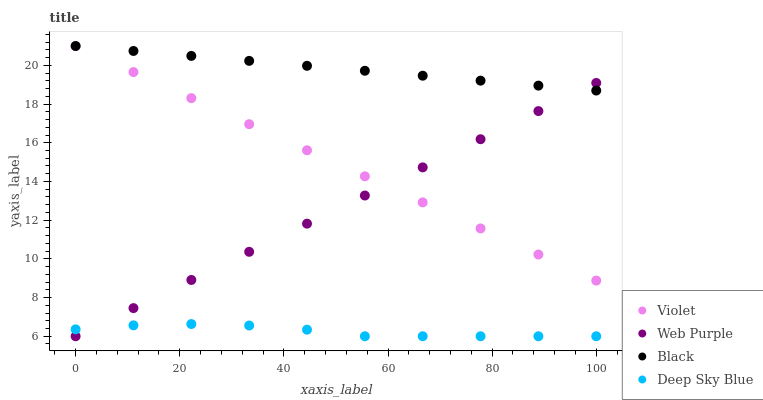Does Deep Sky Blue have the minimum area under the curve?
Answer yes or no. Yes. Does Black have the maximum area under the curve?
Answer yes or no. Yes. Does Black have the minimum area under the curve?
Answer yes or no. No. Does Deep Sky Blue have the maximum area under the curve?
Answer yes or no. No. Is Web Purple the smoothest?
Answer yes or no. Yes. Is Deep Sky Blue the roughest?
Answer yes or no. Yes. Is Black the smoothest?
Answer yes or no. No. Is Black the roughest?
Answer yes or no. No. Does Web Purple have the lowest value?
Answer yes or no. Yes. Does Black have the lowest value?
Answer yes or no. No. Does Violet have the highest value?
Answer yes or no. Yes. Does Deep Sky Blue have the highest value?
Answer yes or no. No. Is Deep Sky Blue less than Black?
Answer yes or no. Yes. Is Violet greater than Deep Sky Blue?
Answer yes or no. Yes. Does Violet intersect Web Purple?
Answer yes or no. Yes. Is Violet less than Web Purple?
Answer yes or no. No. Is Violet greater than Web Purple?
Answer yes or no. No. Does Deep Sky Blue intersect Black?
Answer yes or no. No. 